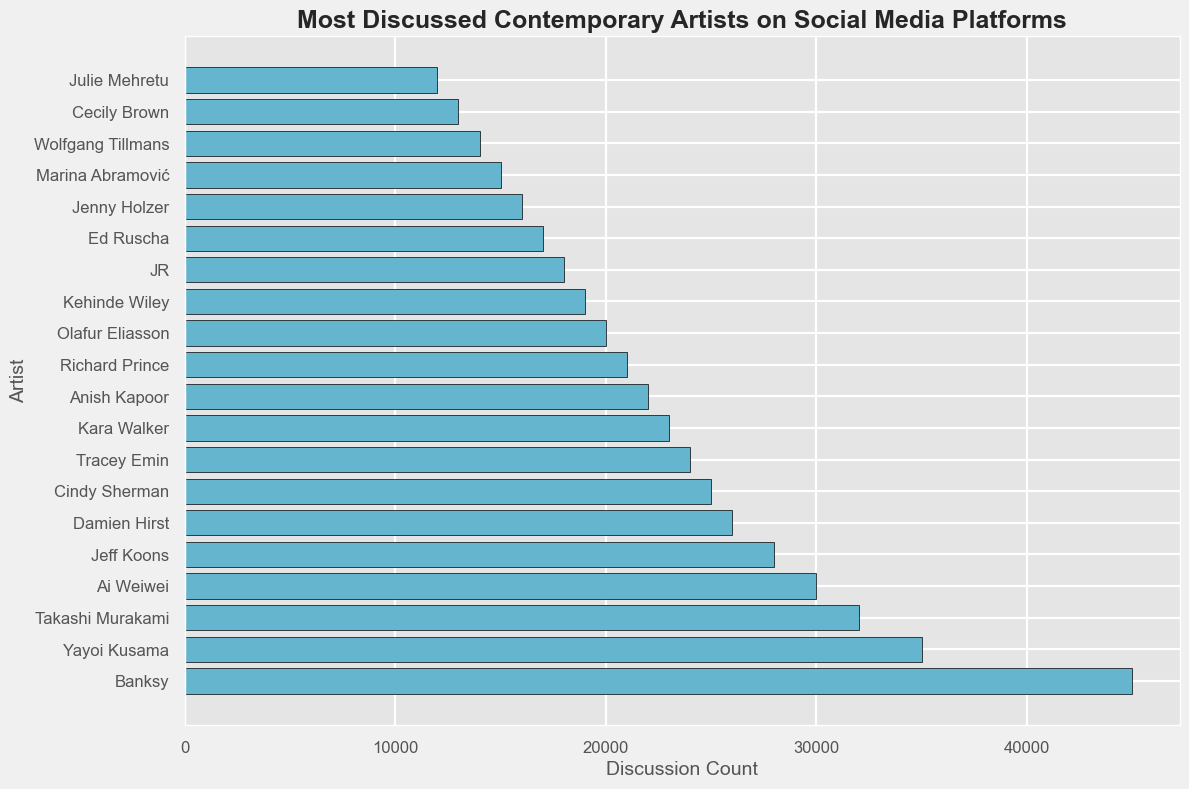What's the discussion count for the most talked-about artist? Look at the bar with the highest value. Banksy has the highest discussion count on the chart.
Answer: 45000 Which artist has a lower discussion count: Jeff Koons or Damien Hirst? Compare the heights of the bars corresponding to Jeff Koons and Damien Hirst. Jeff Koons has a discussion count of 28000, while Damien Hirst has 26000, making Hirst's count lower.
Answer: Damien Hirst What is the total discussion count for the top three artists? Sum the discussion counts of the top three artists: Banksy (45000), Yayoi Kusama (35000), and Takashi Murakami (32000). 45000 + 35000 + 32000 = 112000.
Answer: 112000 Who ranks just below Kara Walker in discussion count, and what is their count? Identify the artist right after Kara Walker. Anish Kapoor follows with a discussion count of 22000.
Answer: Anish Kapoor, 22000 How does the discussion count of Cindy Sherman compare to that of Julie Mehretu? Find both artists on the chart and compare the heights of their bars. Cindy Sherman has 25000, and Julie Mehretu has 12000, so Cindy Sherman has a higher discussion count.
Answer: Cindy Sherman has a higher count Which artist is directly in the middle of the chart in terms of discussion count? Determine the median artist on the list by finding the middle one when sorted. Tracey Emin is the 10th artist in a sorted list from 1 to 20.
Answer: Tracey Emin What's the average discussion count of the bottom five artists on the chart? Look at the lowest five values: JR (18000), Ed Ruscha (17000), Jenny Holzer (16000), Marina Abramović (15000), Wolfgang Tillmans (14000). Sum these and divide by 5. (18000 + 17000 + 16000 + 15000 + 14000) / 5 = 16000.
Answer: 16000 What is the discussion count range of the artists displayed? Identify the highest and lowest values on the chart. The highest is Banksy (45000), and the lowest is Julie Mehretu (12000). Range = 45000 - 12000.
Answer: 33000 How many artists have a discussion count greater than or equal to 25000? Count the number of artists with discussion counts 25000 or higher: Banksy, Yayoi Kusama, Takashi Murakami, Ai Weiwei, Jeff Koons, Damien Hirst, Cindy Sherman. This gives a total of 7.
Answer: 7 Which artist has the discussion count closest to 20000? Look at the artist whose discussion count is nearest to 20000. Olafur Eliasson has exactly 20000, so he's the closest.
Answer: Olafur Eliasson 